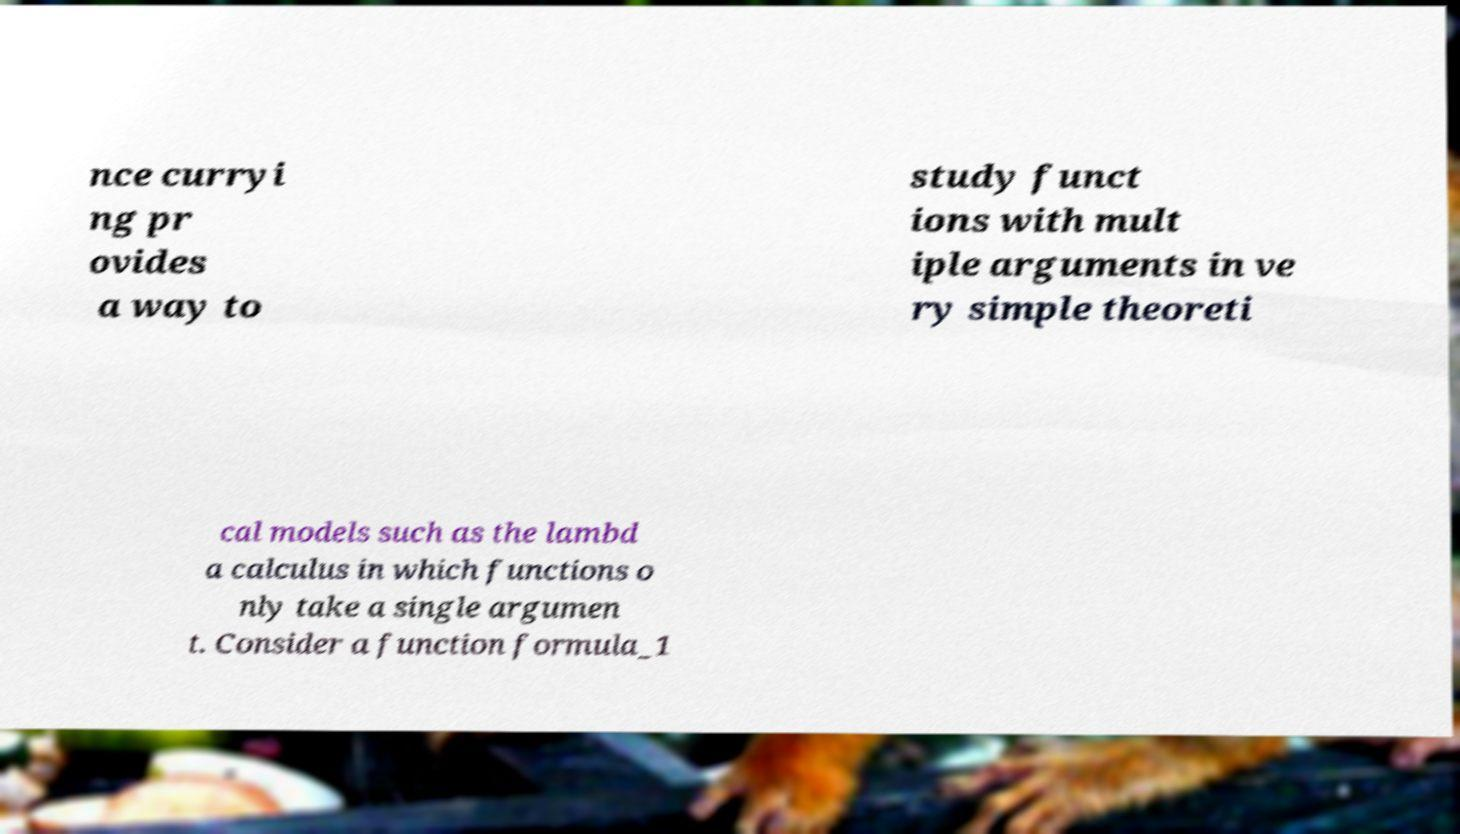Could you extract and type out the text from this image? nce curryi ng pr ovides a way to study funct ions with mult iple arguments in ve ry simple theoreti cal models such as the lambd a calculus in which functions o nly take a single argumen t. Consider a function formula_1 